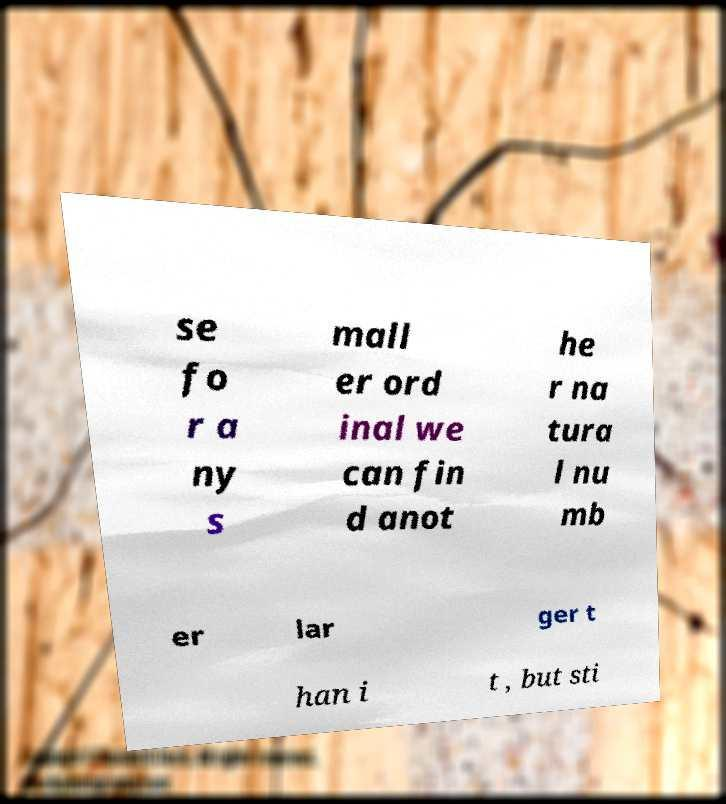Can you accurately transcribe the text from the provided image for me? se fo r a ny s mall er ord inal we can fin d anot he r na tura l nu mb er lar ger t han i t , but sti 